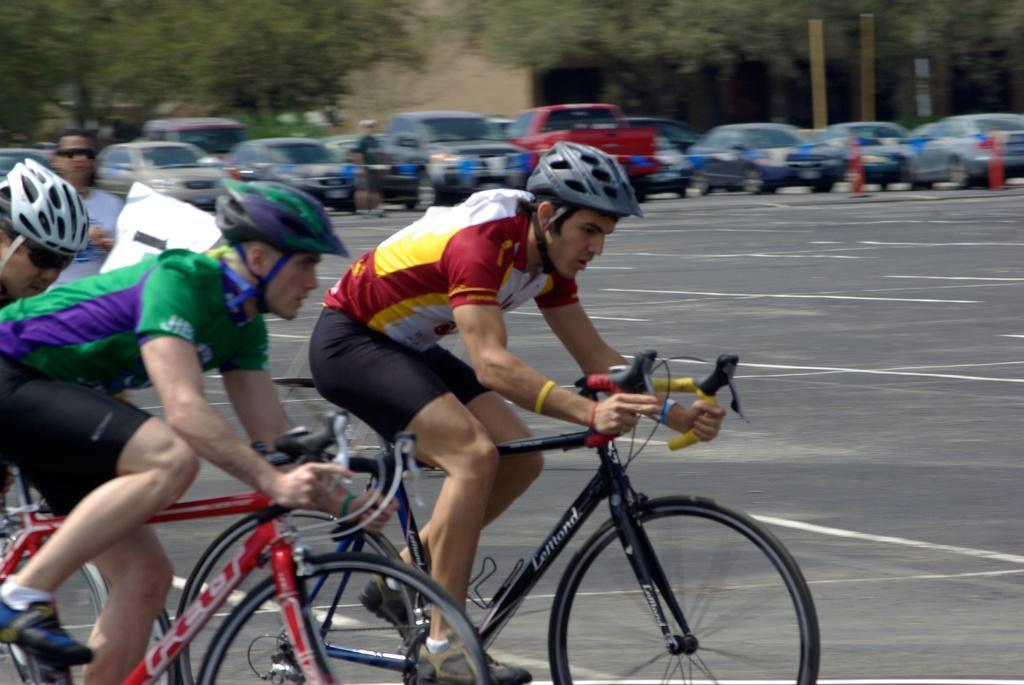In one or two sentences, can you explain what this image depicts? In this image, we can see few people are riding bicycles and wearing helmets. On the left side, a person is standing on the road. Background there are so many vehicles. Here there is another person is standing. Top of the image, we can see a wall, trees. 